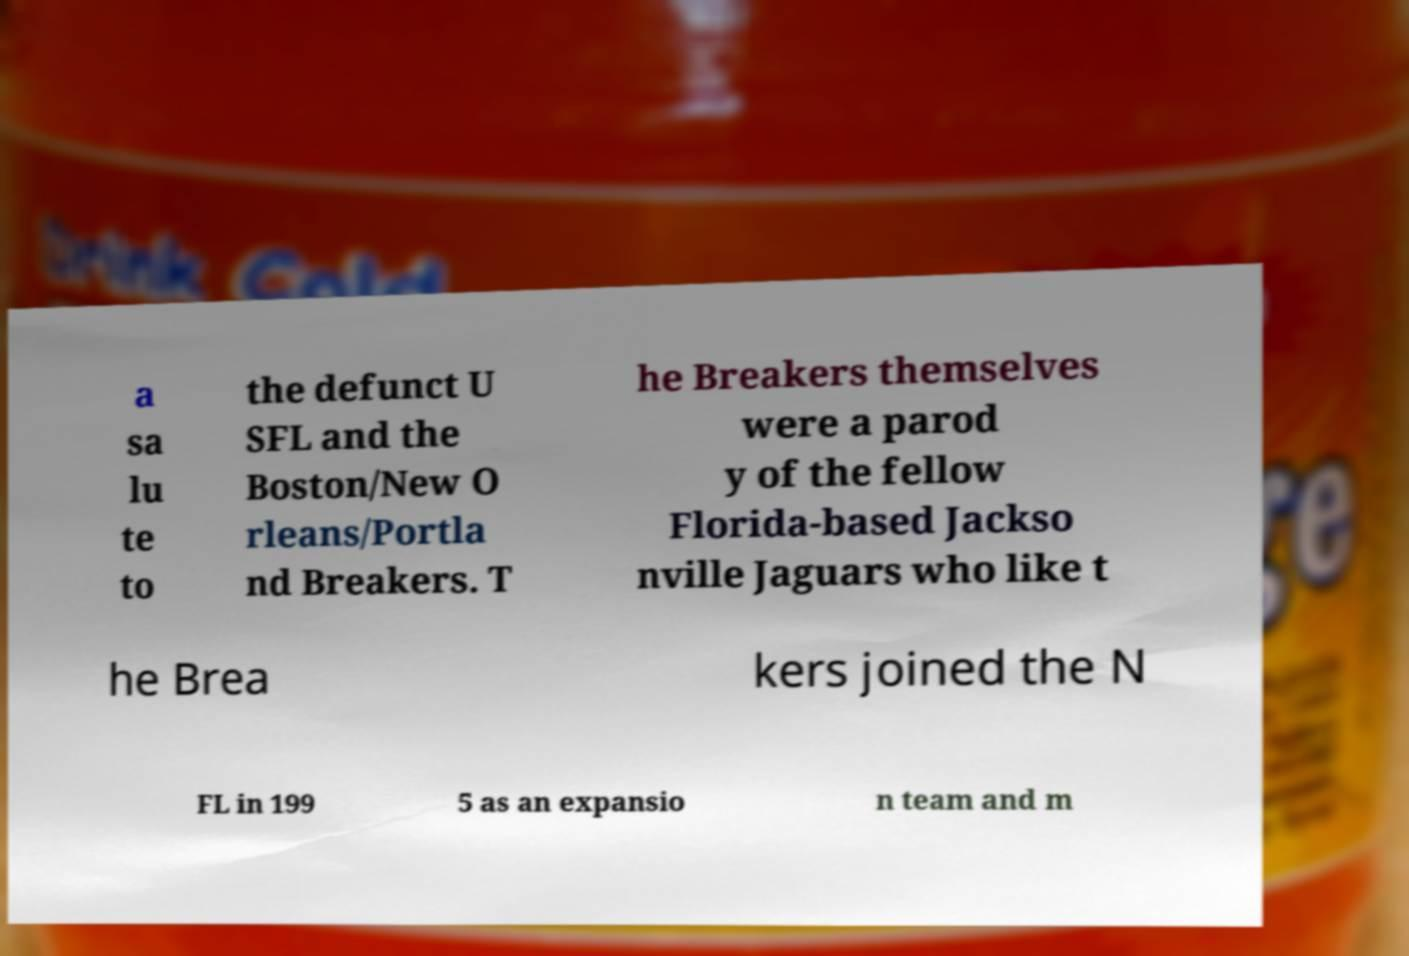Can you accurately transcribe the text from the provided image for me? a sa lu te to the defunct U SFL and the Boston/New O rleans/Portla nd Breakers. T he Breakers themselves were a parod y of the fellow Florida-based Jackso nville Jaguars who like t he Brea kers joined the N FL in 199 5 as an expansio n team and m 